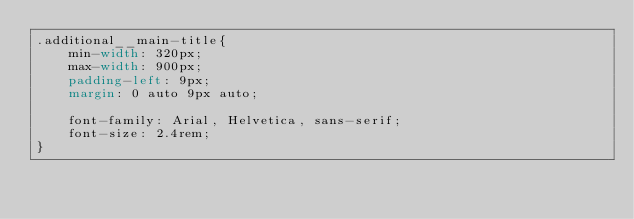<code> <loc_0><loc_0><loc_500><loc_500><_CSS_>.additional__main-title{
    min-width: 320px;
    max-width: 900px;
    padding-left: 9px;
    margin: 0 auto 9px auto;

    font-family: Arial, Helvetica, sans-serif;
    font-size: 2.4rem;
}
</code> 